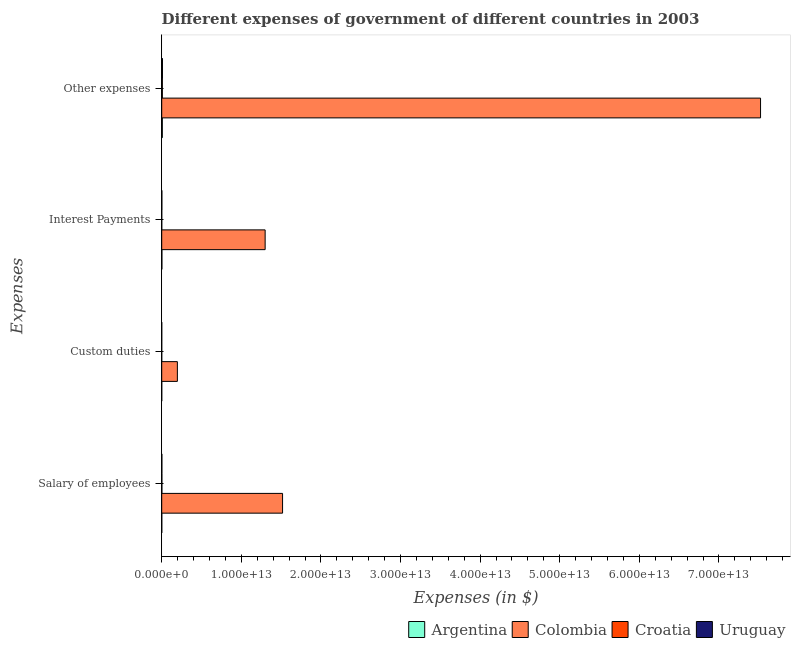How many different coloured bars are there?
Offer a terse response. 4. Are the number of bars on each tick of the Y-axis equal?
Offer a terse response. Yes. How many bars are there on the 3rd tick from the bottom?
Your response must be concise. 4. What is the label of the 4th group of bars from the top?
Provide a succinct answer. Salary of employees. What is the amount spent on salary of employees in Uruguay?
Your answer should be compact. 1.98e+1. Across all countries, what is the maximum amount spent on salary of employees?
Make the answer very short. 1.52e+13. Across all countries, what is the minimum amount spent on custom duties?
Provide a succinct answer. 1.81e+09. What is the total amount spent on other expenses in the graph?
Keep it short and to the point. 7.55e+13. What is the difference between the amount spent on other expenses in Colombia and that in Uruguay?
Make the answer very short. 7.51e+13. What is the difference between the amount spent on salary of employees in Uruguay and the amount spent on other expenses in Argentina?
Provide a short and direct response. -5.47e+1. What is the average amount spent on other expenses per country?
Ensure brevity in your answer.  1.89e+13. What is the difference between the amount spent on salary of employees and amount spent on other expenses in Uruguay?
Offer a very short reply. -7.50e+1. What is the ratio of the amount spent on salary of employees in Argentina to that in Croatia?
Keep it short and to the point. 0.39. Is the amount spent on custom duties in Colombia less than that in Argentina?
Your answer should be very brief. No. What is the difference between the highest and the second highest amount spent on interest payments?
Provide a succinct answer. 1.30e+13. What is the difference between the highest and the lowest amount spent on interest payments?
Provide a succinct answer. 1.30e+13. In how many countries, is the amount spent on salary of employees greater than the average amount spent on salary of employees taken over all countries?
Make the answer very short. 1. What does the 4th bar from the top in Interest Payments represents?
Your answer should be very brief. Argentina. What is the difference between two consecutive major ticks on the X-axis?
Keep it short and to the point. 1.00e+13. Does the graph contain grids?
Give a very brief answer. No. How are the legend labels stacked?
Your answer should be very brief. Horizontal. What is the title of the graph?
Keep it short and to the point. Different expenses of government of different countries in 2003. What is the label or title of the X-axis?
Your response must be concise. Expenses (in $). What is the label or title of the Y-axis?
Ensure brevity in your answer.  Expenses. What is the Expenses (in $) in Argentina in Salary of employees?
Offer a very short reply. 8.70e+09. What is the Expenses (in $) in Colombia in Salary of employees?
Your response must be concise. 1.52e+13. What is the Expenses (in $) in Croatia in Salary of employees?
Ensure brevity in your answer.  2.21e+1. What is the Expenses (in $) of Uruguay in Salary of employees?
Keep it short and to the point. 1.98e+1. What is the Expenses (in $) in Argentina in Custom duties?
Provide a succinct answer. 2.21e+09. What is the Expenses (in $) of Colombia in Custom duties?
Ensure brevity in your answer.  1.97e+12. What is the Expenses (in $) in Croatia in Custom duties?
Provide a succinct answer. 1.81e+09. What is the Expenses (in $) in Uruguay in Custom duties?
Provide a succinct answer. 3.75e+09. What is the Expenses (in $) of Argentina in Interest Payments?
Make the answer very short. 2.24e+1. What is the Expenses (in $) in Colombia in Interest Payments?
Make the answer very short. 1.30e+13. What is the Expenses (in $) of Croatia in Interest Payments?
Provide a short and direct response. 3.96e+09. What is the Expenses (in $) of Uruguay in Interest Payments?
Ensure brevity in your answer.  1.78e+1. What is the Expenses (in $) in Argentina in Other expenses?
Give a very brief answer. 7.46e+1. What is the Expenses (in $) of Colombia in Other expenses?
Your answer should be very brief. 7.52e+13. What is the Expenses (in $) of Croatia in Other expenses?
Offer a very short reply. 8.07e+1. What is the Expenses (in $) in Uruguay in Other expenses?
Your response must be concise. 9.48e+1. Across all Expenses, what is the maximum Expenses (in $) in Argentina?
Provide a succinct answer. 7.46e+1. Across all Expenses, what is the maximum Expenses (in $) of Colombia?
Offer a very short reply. 7.52e+13. Across all Expenses, what is the maximum Expenses (in $) in Croatia?
Your answer should be compact. 8.07e+1. Across all Expenses, what is the maximum Expenses (in $) in Uruguay?
Ensure brevity in your answer.  9.48e+1. Across all Expenses, what is the minimum Expenses (in $) of Argentina?
Provide a short and direct response. 2.21e+09. Across all Expenses, what is the minimum Expenses (in $) of Colombia?
Provide a short and direct response. 1.97e+12. Across all Expenses, what is the minimum Expenses (in $) in Croatia?
Give a very brief answer. 1.81e+09. Across all Expenses, what is the minimum Expenses (in $) in Uruguay?
Keep it short and to the point. 3.75e+09. What is the total Expenses (in $) of Argentina in the graph?
Ensure brevity in your answer.  1.08e+11. What is the total Expenses (in $) of Colombia in the graph?
Ensure brevity in your answer.  1.05e+14. What is the total Expenses (in $) of Croatia in the graph?
Keep it short and to the point. 1.09e+11. What is the total Expenses (in $) of Uruguay in the graph?
Provide a short and direct response. 1.36e+11. What is the difference between the Expenses (in $) of Argentina in Salary of employees and that in Custom duties?
Offer a very short reply. 6.49e+09. What is the difference between the Expenses (in $) of Colombia in Salary of employees and that in Custom duties?
Give a very brief answer. 1.32e+13. What is the difference between the Expenses (in $) in Croatia in Salary of employees and that in Custom duties?
Offer a very short reply. 2.03e+1. What is the difference between the Expenses (in $) of Uruguay in Salary of employees and that in Custom duties?
Make the answer very short. 1.61e+1. What is the difference between the Expenses (in $) of Argentina in Salary of employees and that in Interest Payments?
Keep it short and to the point. -1.37e+1. What is the difference between the Expenses (in $) in Colombia in Salary of employees and that in Interest Payments?
Provide a succinct answer. 2.19e+12. What is the difference between the Expenses (in $) of Croatia in Salary of employees and that in Interest Payments?
Ensure brevity in your answer.  1.81e+1. What is the difference between the Expenses (in $) in Uruguay in Salary of employees and that in Interest Payments?
Provide a succinct answer. 2.02e+09. What is the difference between the Expenses (in $) of Argentina in Salary of employees and that in Other expenses?
Your response must be concise. -6.59e+1. What is the difference between the Expenses (in $) in Colombia in Salary of employees and that in Other expenses?
Provide a short and direct response. -6.00e+13. What is the difference between the Expenses (in $) in Croatia in Salary of employees and that in Other expenses?
Your answer should be very brief. -5.86e+1. What is the difference between the Expenses (in $) in Uruguay in Salary of employees and that in Other expenses?
Offer a terse response. -7.50e+1. What is the difference between the Expenses (in $) in Argentina in Custom duties and that in Interest Payments?
Keep it short and to the point. -2.02e+1. What is the difference between the Expenses (in $) in Colombia in Custom duties and that in Interest Payments?
Make the answer very short. -1.10e+13. What is the difference between the Expenses (in $) of Croatia in Custom duties and that in Interest Payments?
Your response must be concise. -2.15e+09. What is the difference between the Expenses (in $) in Uruguay in Custom duties and that in Interest Payments?
Ensure brevity in your answer.  -1.40e+1. What is the difference between the Expenses (in $) of Argentina in Custom duties and that in Other expenses?
Your answer should be very brief. -7.24e+1. What is the difference between the Expenses (in $) of Colombia in Custom duties and that in Other expenses?
Make the answer very short. -7.33e+13. What is the difference between the Expenses (in $) in Croatia in Custom duties and that in Other expenses?
Your answer should be compact. -7.89e+1. What is the difference between the Expenses (in $) in Uruguay in Custom duties and that in Other expenses?
Your answer should be very brief. -9.11e+1. What is the difference between the Expenses (in $) of Argentina in Interest Payments and that in Other expenses?
Make the answer very short. -5.22e+1. What is the difference between the Expenses (in $) of Colombia in Interest Payments and that in Other expenses?
Offer a very short reply. -6.22e+13. What is the difference between the Expenses (in $) of Croatia in Interest Payments and that in Other expenses?
Your response must be concise. -7.68e+1. What is the difference between the Expenses (in $) in Uruguay in Interest Payments and that in Other expenses?
Offer a terse response. -7.70e+1. What is the difference between the Expenses (in $) of Argentina in Salary of employees and the Expenses (in $) of Colombia in Custom duties?
Your answer should be compact. -1.96e+12. What is the difference between the Expenses (in $) of Argentina in Salary of employees and the Expenses (in $) of Croatia in Custom duties?
Provide a succinct answer. 6.89e+09. What is the difference between the Expenses (in $) of Argentina in Salary of employees and the Expenses (in $) of Uruguay in Custom duties?
Your response must be concise. 4.95e+09. What is the difference between the Expenses (in $) in Colombia in Salary of employees and the Expenses (in $) in Croatia in Custom duties?
Your answer should be very brief. 1.52e+13. What is the difference between the Expenses (in $) of Colombia in Salary of employees and the Expenses (in $) of Uruguay in Custom duties?
Your answer should be very brief. 1.52e+13. What is the difference between the Expenses (in $) in Croatia in Salary of employees and the Expenses (in $) in Uruguay in Custom duties?
Your answer should be compact. 1.83e+1. What is the difference between the Expenses (in $) of Argentina in Salary of employees and the Expenses (in $) of Colombia in Interest Payments?
Keep it short and to the point. -1.30e+13. What is the difference between the Expenses (in $) of Argentina in Salary of employees and the Expenses (in $) of Croatia in Interest Payments?
Your response must be concise. 4.75e+09. What is the difference between the Expenses (in $) in Argentina in Salary of employees and the Expenses (in $) in Uruguay in Interest Payments?
Offer a very short reply. -9.10e+09. What is the difference between the Expenses (in $) in Colombia in Salary of employees and the Expenses (in $) in Croatia in Interest Payments?
Make the answer very short. 1.52e+13. What is the difference between the Expenses (in $) of Colombia in Salary of employees and the Expenses (in $) of Uruguay in Interest Payments?
Provide a succinct answer. 1.52e+13. What is the difference between the Expenses (in $) in Croatia in Salary of employees and the Expenses (in $) in Uruguay in Interest Payments?
Provide a succinct answer. 4.27e+09. What is the difference between the Expenses (in $) of Argentina in Salary of employees and the Expenses (in $) of Colombia in Other expenses?
Give a very brief answer. -7.52e+13. What is the difference between the Expenses (in $) in Argentina in Salary of employees and the Expenses (in $) in Croatia in Other expenses?
Your response must be concise. -7.20e+1. What is the difference between the Expenses (in $) of Argentina in Salary of employees and the Expenses (in $) of Uruguay in Other expenses?
Give a very brief answer. -8.61e+1. What is the difference between the Expenses (in $) of Colombia in Salary of employees and the Expenses (in $) of Croatia in Other expenses?
Your answer should be compact. 1.51e+13. What is the difference between the Expenses (in $) of Colombia in Salary of employees and the Expenses (in $) of Uruguay in Other expenses?
Keep it short and to the point. 1.51e+13. What is the difference between the Expenses (in $) of Croatia in Salary of employees and the Expenses (in $) of Uruguay in Other expenses?
Offer a very short reply. -7.28e+1. What is the difference between the Expenses (in $) of Argentina in Custom duties and the Expenses (in $) of Colombia in Interest Payments?
Offer a terse response. -1.30e+13. What is the difference between the Expenses (in $) in Argentina in Custom duties and the Expenses (in $) in Croatia in Interest Payments?
Ensure brevity in your answer.  -1.74e+09. What is the difference between the Expenses (in $) of Argentina in Custom duties and the Expenses (in $) of Uruguay in Interest Payments?
Offer a terse response. -1.56e+1. What is the difference between the Expenses (in $) of Colombia in Custom duties and the Expenses (in $) of Croatia in Interest Payments?
Your response must be concise. 1.96e+12. What is the difference between the Expenses (in $) in Colombia in Custom duties and the Expenses (in $) in Uruguay in Interest Payments?
Provide a short and direct response. 1.95e+12. What is the difference between the Expenses (in $) in Croatia in Custom duties and the Expenses (in $) in Uruguay in Interest Payments?
Give a very brief answer. -1.60e+1. What is the difference between the Expenses (in $) of Argentina in Custom duties and the Expenses (in $) of Colombia in Other expenses?
Keep it short and to the point. -7.52e+13. What is the difference between the Expenses (in $) of Argentina in Custom duties and the Expenses (in $) of Croatia in Other expenses?
Give a very brief answer. -7.85e+1. What is the difference between the Expenses (in $) in Argentina in Custom duties and the Expenses (in $) in Uruguay in Other expenses?
Provide a short and direct response. -9.26e+1. What is the difference between the Expenses (in $) of Colombia in Custom duties and the Expenses (in $) of Croatia in Other expenses?
Your answer should be compact. 1.89e+12. What is the difference between the Expenses (in $) of Colombia in Custom duties and the Expenses (in $) of Uruguay in Other expenses?
Keep it short and to the point. 1.87e+12. What is the difference between the Expenses (in $) in Croatia in Custom duties and the Expenses (in $) in Uruguay in Other expenses?
Keep it short and to the point. -9.30e+1. What is the difference between the Expenses (in $) in Argentina in Interest Payments and the Expenses (in $) in Colombia in Other expenses?
Offer a very short reply. -7.52e+13. What is the difference between the Expenses (in $) in Argentina in Interest Payments and the Expenses (in $) in Croatia in Other expenses?
Ensure brevity in your answer.  -5.83e+1. What is the difference between the Expenses (in $) in Argentina in Interest Payments and the Expenses (in $) in Uruguay in Other expenses?
Your response must be concise. -7.25e+1. What is the difference between the Expenses (in $) of Colombia in Interest Payments and the Expenses (in $) of Croatia in Other expenses?
Your answer should be very brief. 1.29e+13. What is the difference between the Expenses (in $) in Colombia in Interest Payments and the Expenses (in $) in Uruguay in Other expenses?
Give a very brief answer. 1.29e+13. What is the difference between the Expenses (in $) in Croatia in Interest Payments and the Expenses (in $) in Uruguay in Other expenses?
Your response must be concise. -9.09e+1. What is the average Expenses (in $) of Argentina per Expenses?
Make the answer very short. 2.70e+1. What is the average Expenses (in $) in Colombia per Expenses?
Give a very brief answer. 2.63e+13. What is the average Expenses (in $) of Croatia per Expenses?
Provide a succinct answer. 2.71e+1. What is the average Expenses (in $) in Uruguay per Expenses?
Offer a terse response. 3.41e+1. What is the difference between the Expenses (in $) in Argentina and Expenses (in $) in Colombia in Salary of employees?
Your answer should be compact. -1.52e+13. What is the difference between the Expenses (in $) in Argentina and Expenses (in $) in Croatia in Salary of employees?
Offer a terse response. -1.34e+1. What is the difference between the Expenses (in $) in Argentina and Expenses (in $) in Uruguay in Salary of employees?
Ensure brevity in your answer.  -1.11e+1. What is the difference between the Expenses (in $) of Colombia and Expenses (in $) of Croatia in Salary of employees?
Your answer should be compact. 1.52e+13. What is the difference between the Expenses (in $) of Colombia and Expenses (in $) of Uruguay in Salary of employees?
Provide a short and direct response. 1.52e+13. What is the difference between the Expenses (in $) of Croatia and Expenses (in $) of Uruguay in Salary of employees?
Make the answer very short. 2.25e+09. What is the difference between the Expenses (in $) of Argentina and Expenses (in $) of Colombia in Custom duties?
Offer a very short reply. -1.97e+12. What is the difference between the Expenses (in $) in Argentina and Expenses (in $) in Croatia in Custom duties?
Provide a succinct answer. 4.01e+08. What is the difference between the Expenses (in $) of Argentina and Expenses (in $) of Uruguay in Custom duties?
Give a very brief answer. -1.54e+09. What is the difference between the Expenses (in $) in Colombia and Expenses (in $) in Croatia in Custom duties?
Offer a very short reply. 1.97e+12. What is the difference between the Expenses (in $) of Colombia and Expenses (in $) of Uruguay in Custom duties?
Give a very brief answer. 1.96e+12. What is the difference between the Expenses (in $) in Croatia and Expenses (in $) in Uruguay in Custom duties?
Your answer should be compact. -1.94e+09. What is the difference between the Expenses (in $) in Argentina and Expenses (in $) in Colombia in Interest Payments?
Your response must be concise. -1.30e+13. What is the difference between the Expenses (in $) of Argentina and Expenses (in $) of Croatia in Interest Payments?
Offer a very short reply. 1.84e+1. What is the difference between the Expenses (in $) in Argentina and Expenses (in $) in Uruguay in Interest Payments?
Provide a short and direct response. 4.57e+09. What is the difference between the Expenses (in $) in Colombia and Expenses (in $) in Croatia in Interest Payments?
Provide a short and direct response. 1.30e+13. What is the difference between the Expenses (in $) of Colombia and Expenses (in $) of Uruguay in Interest Payments?
Your answer should be very brief. 1.30e+13. What is the difference between the Expenses (in $) of Croatia and Expenses (in $) of Uruguay in Interest Payments?
Keep it short and to the point. -1.38e+1. What is the difference between the Expenses (in $) in Argentina and Expenses (in $) in Colombia in Other expenses?
Your answer should be very brief. -7.52e+13. What is the difference between the Expenses (in $) of Argentina and Expenses (in $) of Croatia in Other expenses?
Offer a terse response. -6.14e+09. What is the difference between the Expenses (in $) of Argentina and Expenses (in $) of Uruguay in Other expenses?
Offer a very short reply. -2.03e+1. What is the difference between the Expenses (in $) in Colombia and Expenses (in $) in Croatia in Other expenses?
Your response must be concise. 7.51e+13. What is the difference between the Expenses (in $) of Colombia and Expenses (in $) of Uruguay in Other expenses?
Offer a very short reply. 7.51e+13. What is the difference between the Expenses (in $) in Croatia and Expenses (in $) in Uruguay in Other expenses?
Offer a very short reply. -1.41e+1. What is the ratio of the Expenses (in $) of Argentina in Salary of employees to that in Custom duties?
Your answer should be compact. 3.93. What is the ratio of the Expenses (in $) in Colombia in Salary of employees to that in Custom duties?
Keep it short and to the point. 7.72. What is the ratio of the Expenses (in $) of Croatia in Salary of employees to that in Custom duties?
Your answer should be very brief. 12.19. What is the ratio of the Expenses (in $) of Uruguay in Salary of employees to that in Custom duties?
Provide a short and direct response. 5.28. What is the ratio of the Expenses (in $) of Argentina in Salary of employees to that in Interest Payments?
Provide a short and direct response. 0.39. What is the ratio of the Expenses (in $) in Colombia in Salary of employees to that in Interest Payments?
Offer a very short reply. 1.17. What is the ratio of the Expenses (in $) in Croatia in Salary of employees to that in Interest Payments?
Provide a short and direct response. 5.58. What is the ratio of the Expenses (in $) of Uruguay in Salary of employees to that in Interest Payments?
Provide a short and direct response. 1.11. What is the ratio of the Expenses (in $) of Argentina in Salary of employees to that in Other expenses?
Your answer should be very brief. 0.12. What is the ratio of the Expenses (in $) of Colombia in Salary of employees to that in Other expenses?
Offer a terse response. 0.2. What is the ratio of the Expenses (in $) in Croatia in Salary of employees to that in Other expenses?
Ensure brevity in your answer.  0.27. What is the ratio of the Expenses (in $) of Uruguay in Salary of employees to that in Other expenses?
Provide a short and direct response. 0.21. What is the ratio of the Expenses (in $) in Argentina in Custom duties to that in Interest Payments?
Ensure brevity in your answer.  0.1. What is the ratio of the Expenses (in $) of Colombia in Custom duties to that in Interest Payments?
Ensure brevity in your answer.  0.15. What is the ratio of the Expenses (in $) in Croatia in Custom duties to that in Interest Payments?
Provide a short and direct response. 0.46. What is the ratio of the Expenses (in $) in Uruguay in Custom duties to that in Interest Payments?
Ensure brevity in your answer.  0.21. What is the ratio of the Expenses (in $) of Argentina in Custom duties to that in Other expenses?
Make the answer very short. 0.03. What is the ratio of the Expenses (in $) in Colombia in Custom duties to that in Other expenses?
Keep it short and to the point. 0.03. What is the ratio of the Expenses (in $) of Croatia in Custom duties to that in Other expenses?
Keep it short and to the point. 0.02. What is the ratio of the Expenses (in $) in Uruguay in Custom duties to that in Other expenses?
Offer a very short reply. 0.04. What is the ratio of the Expenses (in $) of Argentina in Interest Payments to that in Other expenses?
Ensure brevity in your answer.  0.3. What is the ratio of the Expenses (in $) of Colombia in Interest Payments to that in Other expenses?
Your response must be concise. 0.17. What is the ratio of the Expenses (in $) of Croatia in Interest Payments to that in Other expenses?
Your response must be concise. 0.05. What is the ratio of the Expenses (in $) of Uruguay in Interest Payments to that in Other expenses?
Make the answer very short. 0.19. What is the difference between the highest and the second highest Expenses (in $) in Argentina?
Your response must be concise. 5.22e+1. What is the difference between the highest and the second highest Expenses (in $) of Colombia?
Offer a terse response. 6.00e+13. What is the difference between the highest and the second highest Expenses (in $) in Croatia?
Keep it short and to the point. 5.86e+1. What is the difference between the highest and the second highest Expenses (in $) of Uruguay?
Provide a succinct answer. 7.50e+1. What is the difference between the highest and the lowest Expenses (in $) in Argentina?
Keep it short and to the point. 7.24e+1. What is the difference between the highest and the lowest Expenses (in $) of Colombia?
Provide a short and direct response. 7.33e+13. What is the difference between the highest and the lowest Expenses (in $) of Croatia?
Ensure brevity in your answer.  7.89e+1. What is the difference between the highest and the lowest Expenses (in $) in Uruguay?
Ensure brevity in your answer.  9.11e+1. 